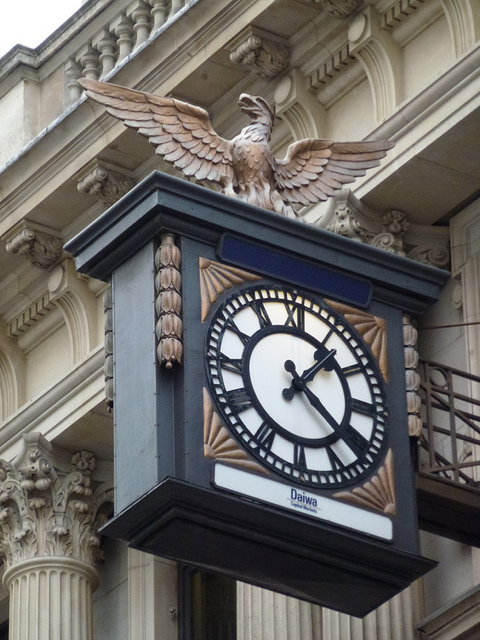Please transcribe the text in this image. Daiwa XI V VII T 